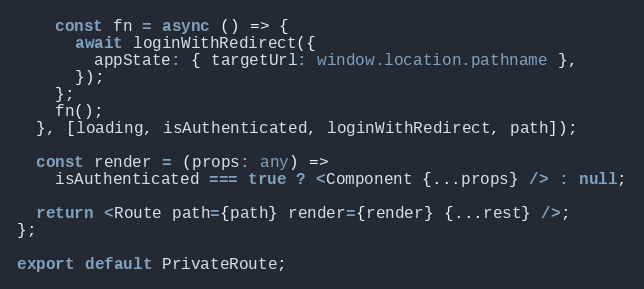<code> <loc_0><loc_0><loc_500><loc_500><_TypeScript_>    const fn = async () => {
      await loginWithRedirect({
        appState: { targetUrl: window.location.pathname },
      });
    };
    fn();
  }, [loading, isAuthenticated, loginWithRedirect, path]);

  const render = (props: any) =>
    isAuthenticated === true ? <Component {...props} /> : null;

  return <Route path={path} render={render} {...rest} />;
};

export default PrivateRoute;
</code> 